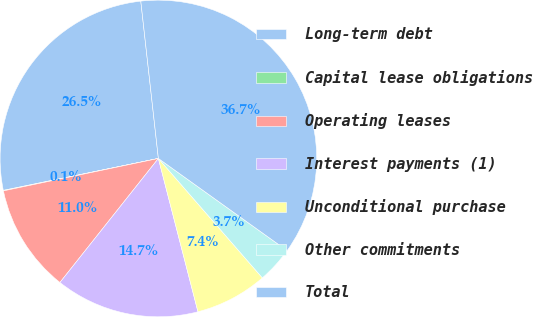Convert chart to OTSL. <chart><loc_0><loc_0><loc_500><loc_500><pie_chart><fcel>Long-term debt<fcel>Capital lease obligations<fcel>Operating leases<fcel>Interest payments (1)<fcel>Unconditional purchase<fcel>Other commitments<fcel>Total<nl><fcel>26.46%<fcel>0.05%<fcel>11.04%<fcel>14.7%<fcel>7.38%<fcel>3.71%<fcel>36.66%<nl></chart> 